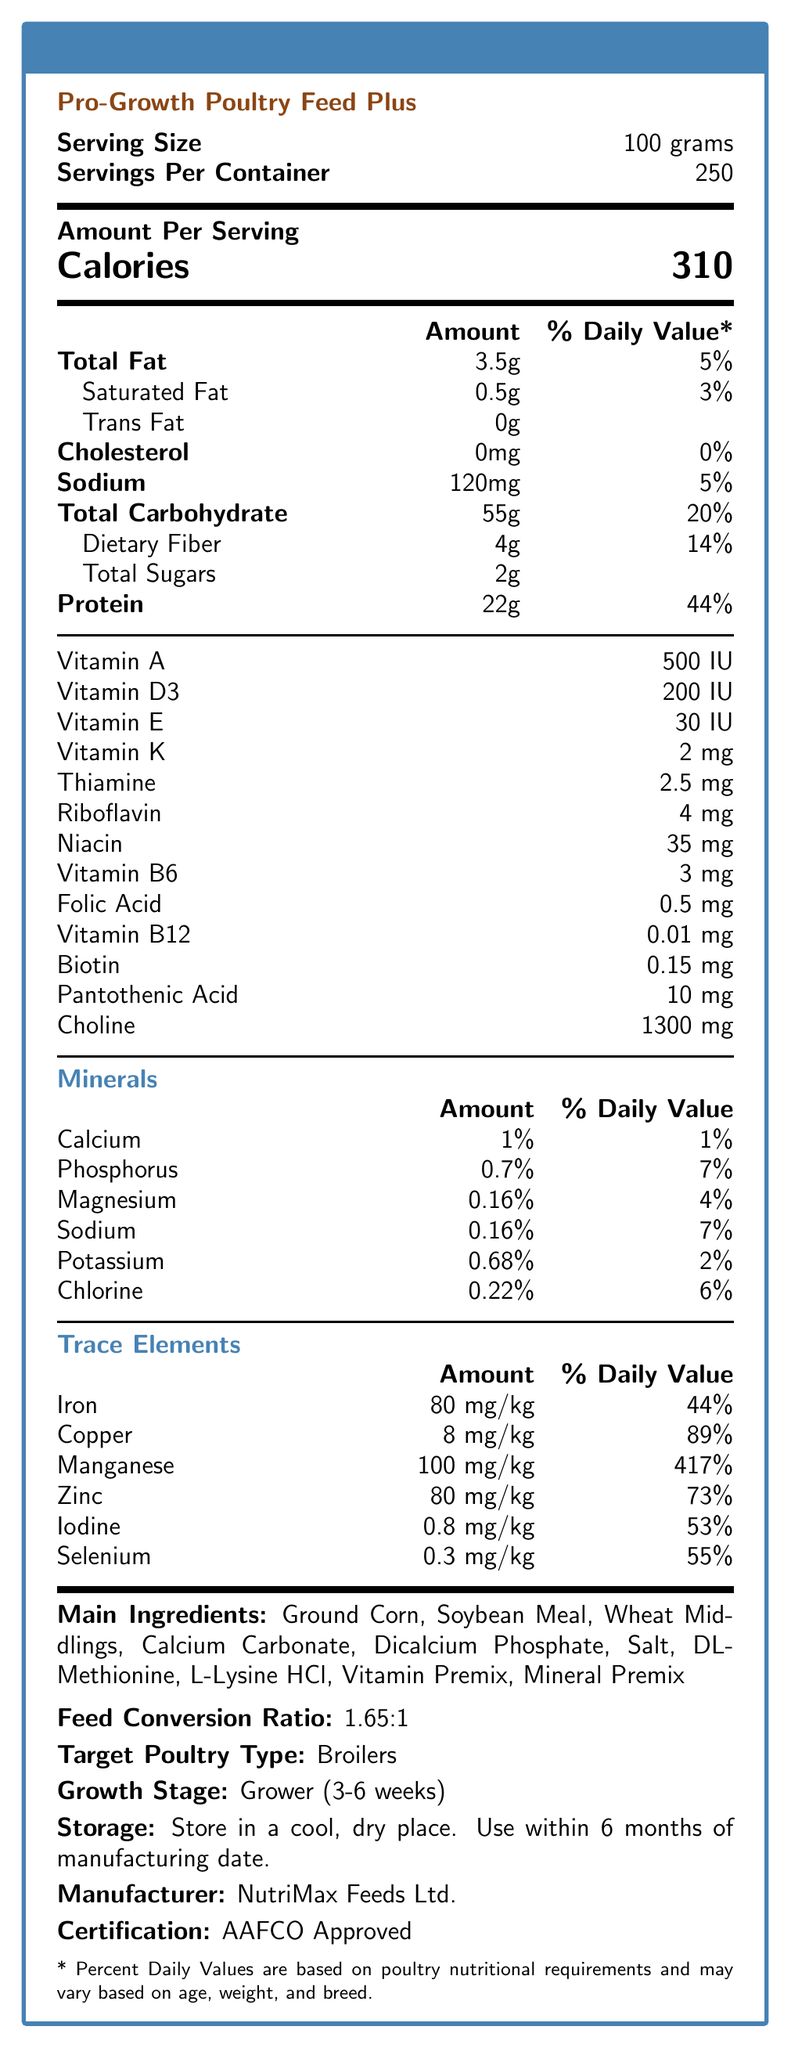what is the serving size of Pro-Growth Poultry Feed Plus? The document states "Serving Size: 100 grams".
Answer: 100 grams how many calories are there per serving? Under "Amount Per Serving," it says "Calories: 310".
Answer: 310 what is the recommended age range for this feed? The document mentions "Growth Stage: Grower (3-6 weeks)".
Answer: 3-6 weeks what is the feed conversion ratio of Pro-Growth Poultry Feed Plus? The document lists "Feed Conversion Ratio: 1.65:1".
Answer: 1.65:1 list at least three main ingredients found in this poultry feed. The text under "Main Ingredients" lists several, including Ground Corn, Soybean Meal, and Wheat Middlings.
Answer: Ground Corn, Soybean Meal, Wheat Middlings which vitamin is present in the highest amount? A. Vitamin A B. Vitamin D3 C. Riboflavin D. Choline Choline is present in the amount of 1300 mg, which is clearly the highest compared to the other vitamins listed.
Answer: D. Choline what percentage of daily value for manganese does the feed provide? A. 44% B. 73% C. 417% D. 55% The document specifies that Manganese provides 417% of the daily value.
Answer: C. 417% is the poultry feed sodium free? The document lists "Sodium: 120mg (5%)" and "Sodium: 0.16% (7%)" under minerals, indicating it contains sodium.
Answer: No does this poultry feed contain any trans fat? The document lists "Trans Fat: 0g," indicating that it contains no trans fat.
Answer: No summarize the information given on the Nutrition Facts Label of Pro-Growth Poultry Feed Plus. The summary encapsulates the feeding guidelines, nutritional breakdown, key ingredients, storage instructions, and certification status of the product.
Answer: Pro-Growth Poultry Feed Plus is targeted for broilers in the grower stage (3-6 weeks), providing calories, macronutrients, vitamins, minerals, and trace elements per 100 grams serving. The feed features a feed conversion ratio of 1.65:1, needs to be stored in a cool, dry place, and carries AAFCO certification. Its key ingredients include ground corn, soybean meal, and wheat middlings. what is the manufacturer of this poultry feed? The bottom of the document states "Manufacturer: NutriMax Feeds Ltd."
Answer: NutriMax Feeds Ltd. what is the amount of protein in grams per serving? The nutrition panel lists "Protein: 22g" under the Amount Per Serving section.
Answer: 22 grams how many servings per container are provided? The document states "Servings Per Container: 250".
Answer: 250 servings per container can one determine the exact requirement of calcium per day for poultry from this document? The document lists the percentage daily value but does not provide details on exact daily requirements for calcium.
Answer: Not enough information what are the storage instructions for this feed? The document specifies "Storage: Store in a cool, dry place. Use within 6 months of manufacturing date."
Answer: Store in a cool, dry place. Use within 6 months of manufacturing date. 